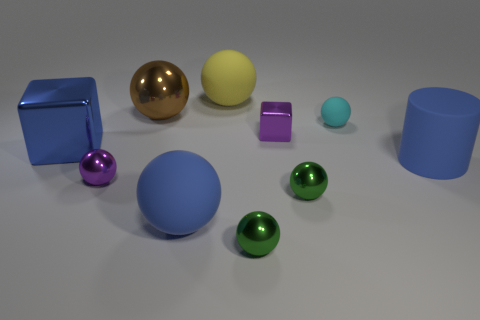Subtract all green metal spheres. How many spheres are left? 5 Subtract all blue blocks. How many green spheres are left? 2 Subtract all cyan balls. How many balls are left? 6 Subtract all yellow balls. Subtract all gray cubes. How many balls are left? 6 Subtract all cylinders. How many objects are left? 9 Add 3 metallic cylinders. How many metallic cylinders exist? 3 Subtract 0 cyan cubes. How many objects are left? 10 Subtract all tiny metallic cubes. Subtract all big blue matte things. How many objects are left? 7 Add 4 green shiny balls. How many green shiny balls are left? 6 